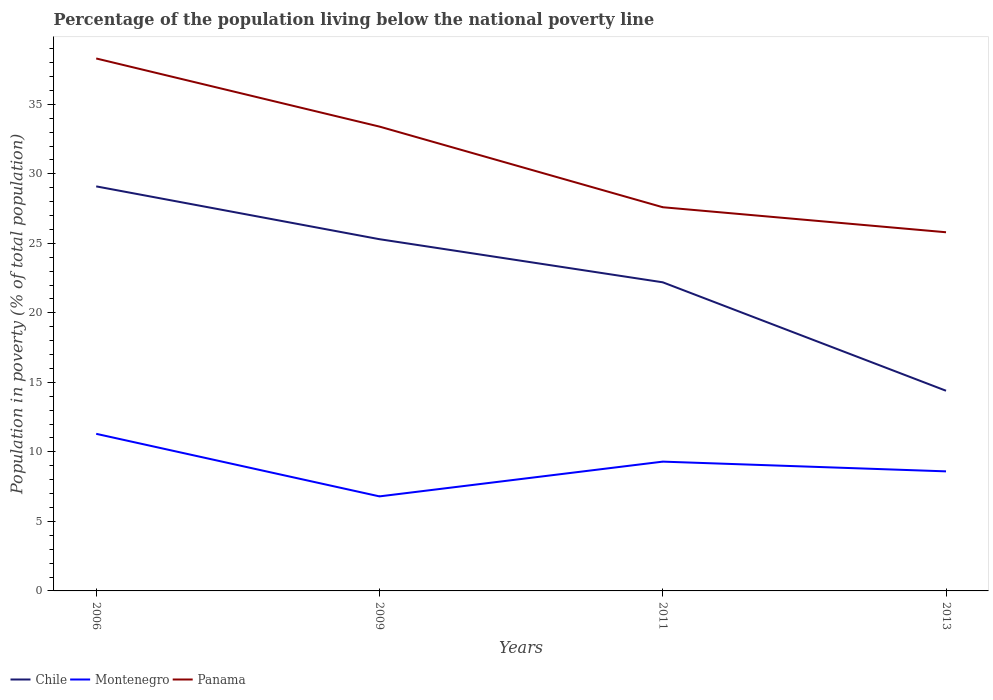How many different coloured lines are there?
Give a very brief answer. 3. Across all years, what is the maximum percentage of the population living below the national poverty line in Montenegro?
Your answer should be very brief. 6.8. In which year was the percentage of the population living below the national poverty line in Panama maximum?
Offer a terse response. 2013. What is the total percentage of the population living below the national poverty line in Montenegro in the graph?
Your answer should be very brief. 0.7. What is the difference between the highest and the second highest percentage of the population living below the national poverty line in Panama?
Give a very brief answer. 12.5. Is the percentage of the population living below the national poverty line in Panama strictly greater than the percentage of the population living below the national poverty line in Chile over the years?
Give a very brief answer. No. How many lines are there?
Keep it short and to the point. 3. What is the difference between two consecutive major ticks on the Y-axis?
Offer a terse response. 5. Are the values on the major ticks of Y-axis written in scientific E-notation?
Provide a short and direct response. No. What is the title of the graph?
Offer a very short reply. Percentage of the population living below the national poverty line. What is the label or title of the Y-axis?
Give a very brief answer. Population in poverty (% of total population). What is the Population in poverty (% of total population) in Chile in 2006?
Make the answer very short. 29.1. What is the Population in poverty (% of total population) in Montenegro in 2006?
Make the answer very short. 11.3. What is the Population in poverty (% of total population) of Panama in 2006?
Make the answer very short. 38.3. What is the Population in poverty (% of total population) of Chile in 2009?
Give a very brief answer. 25.3. What is the Population in poverty (% of total population) of Montenegro in 2009?
Give a very brief answer. 6.8. What is the Population in poverty (% of total population) in Panama in 2009?
Give a very brief answer. 33.4. What is the Population in poverty (% of total population) in Chile in 2011?
Provide a succinct answer. 22.2. What is the Population in poverty (% of total population) of Montenegro in 2011?
Keep it short and to the point. 9.3. What is the Population in poverty (% of total population) of Panama in 2011?
Your response must be concise. 27.6. What is the Population in poverty (% of total population) of Chile in 2013?
Offer a very short reply. 14.4. What is the Population in poverty (% of total population) in Montenegro in 2013?
Provide a short and direct response. 8.6. What is the Population in poverty (% of total population) in Panama in 2013?
Your response must be concise. 25.8. Across all years, what is the maximum Population in poverty (% of total population) in Chile?
Offer a terse response. 29.1. Across all years, what is the maximum Population in poverty (% of total population) in Montenegro?
Provide a succinct answer. 11.3. Across all years, what is the maximum Population in poverty (% of total population) of Panama?
Keep it short and to the point. 38.3. Across all years, what is the minimum Population in poverty (% of total population) of Panama?
Your answer should be very brief. 25.8. What is the total Population in poverty (% of total population) in Chile in the graph?
Ensure brevity in your answer.  91. What is the total Population in poverty (% of total population) of Montenegro in the graph?
Your response must be concise. 36. What is the total Population in poverty (% of total population) in Panama in the graph?
Offer a very short reply. 125.1. What is the difference between the Population in poverty (% of total population) in Montenegro in 2006 and that in 2009?
Provide a succinct answer. 4.5. What is the difference between the Population in poverty (% of total population) in Montenegro in 2006 and that in 2011?
Your response must be concise. 2. What is the difference between the Population in poverty (% of total population) in Chile in 2009 and that in 2011?
Make the answer very short. 3.1. What is the difference between the Population in poverty (% of total population) in Montenegro in 2009 and that in 2013?
Your response must be concise. -1.8. What is the difference between the Population in poverty (% of total population) in Montenegro in 2011 and that in 2013?
Your response must be concise. 0.7. What is the difference between the Population in poverty (% of total population) in Chile in 2006 and the Population in poverty (% of total population) in Montenegro in 2009?
Your answer should be compact. 22.3. What is the difference between the Population in poverty (% of total population) of Montenegro in 2006 and the Population in poverty (% of total population) of Panama in 2009?
Provide a succinct answer. -22.1. What is the difference between the Population in poverty (% of total population) in Chile in 2006 and the Population in poverty (% of total population) in Montenegro in 2011?
Your answer should be compact. 19.8. What is the difference between the Population in poverty (% of total population) in Montenegro in 2006 and the Population in poverty (% of total population) in Panama in 2011?
Your answer should be compact. -16.3. What is the difference between the Population in poverty (% of total population) in Montenegro in 2006 and the Population in poverty (% of total population) in Panama in 2013?
Provide a succinct answer. -14.5. What is the difference between the Population in poverty (% of total population) in Montenegro in 2009 and the Population in poverty (% of total population) in Panama in 2011?
Offer a terse response. -20.8. What is the difference between the Population in poverty (% of total population) of Chile in 2009 and the Population in poverty (% of total population) of Montenegro in 2013?
Offer a very short reply. 16.7. What is the difference between the Population in poverty (% of total population) in Chile in 2009 and the Population in poverty (% of total population) in Panama in 2013?
Your response must be concise. -0.5. What is the difference between the Population in poverty (% of total population) in Chile in 2011 and the Population in poverty (% of total population) in Panama in 2013?
Give a very brief answer. -3.6. What is the difference between the Population in poverty (% of total population) in Montenegro in 2011 and the Population in poverty (% of total population) in Panama in 2013?
Your answer should be very brief. -16.5. What is the average Population in poverty (% of total population) in Chile per year?
Your response must be concise. 22.75. What is the average Population in poverty (% of total population) of Panama per year?
Your response must be concise. 31.27. In the year 2006, what is the difference between the Population in poverty (% of total population) in Montenegro and Population in poverty (% of total population) in Panama?
Provide a succinct answer. -27. In the year 2009, what is the difference between the Population in poverty (% of total population) of Montenegro and Population in poverty (% of total population) of Panama?
Give a very brief answer. -26.6. In the year 2011, what is the difference between the Population in poverty (% of total population) of Chile and Population in poverty (% of total population) of Montenegro?
Provide a succinct answer. 12.9. In the year 2011, what is the difference between the Population in poverty (% of total population) of Montenegro and Population in poverty (% of total population) of Panama?
Your answer should be very brief. -18.3. In the year 2013, what is the difference between the Population in poverty (% of total population) in Chile and Population in poverty (% of total population) in Montenegro?
Ensure brevity in your answer.  5.8. In the year 2013, what is the difference between the Population in poverty (% of total population) of Montenegro and Population in poverty (% of total population) of Panama?
Your response must be concise. -17.2. What is the ratio of the Population in poverty (% of total population) in Chile in 2006 to that in 2009?
Provide a succinct answer. 1.15. What is the ratio of the Population in poverty (% of total population) of Montenegro in 2006 to that in 2009?
Offer a terse response. 1.66. What is the ratio of the Population in poverty (% of total population) of Panama in 2006 to that in 2009?
Provide a short and direct response. 1.15. What is the ratio of the Population in poverty (% of total population) of Chile in 2006 to that in 2011?
Make the answer very short. 1.31. What is the ratio of the Population in poverty (% of total population) of Montenegro in 2006 to that in 2011?
Provide a succinct answer. 1.22. What is the ratio of the Population in poverty (% of total population) in Panama in 2006 to that in 2011?
Offer a terse response. 1.39. What is the ratio of the Population in poverty (% of total population) in Chile in 2006 to that in 2013?
Your answer should be compact. 2.02. What is the ratio of the Population in poverty (% of total population) in Montenegro in 2006 to that in 2013?
Offer a very short reply. 1.31. What is the ratio of the Population in poverty (% of total population) of Panama in 2006 to that in 2013?
Your answer should be very brief. 1.48. What is the ratio of the Population in poverty (% of total population) of Chile in 2009 to that in 2011?
Keep it short and to the point. 1.14. What is the ratio of the Population in poverty (% of total population) of Montenegro in 2009 to that in 2011?
Keep it short and to the point. 0.73. What is the ratio of the Population in poverty (% of total population) of Panama in 2009 to that in 2011?
Your answer should be compact. 1.21. What is the ratio of the Population in poverty (% of total population) in Chile in 2009 to that in 2013?
Keep it short and to the point. 1.76. What is the ratio of the Population in poverty (% of total population) of Montenegro in 2009 to that in 2013?
Keep it short and to the point. 0.79. What is the ratio of the Population in poverty (% of total population) of Panama in 2009 to that in 2013?
Offer a very short reply. 1.29. What is the ratio of the Population in poverty (% of total population) in Chile in 2011 to that in 2013?
Provide a short and direct response. 1.54. What is the ratio of the Population in poverty (% of total population) of Montenegro in 2011 to that in 2013?
Offer a terse response. 1.08. What is the ratio of the Population in poverty (% of total population) of Panama in 2011 to that in 2013?
Provide a succinct answer. 1.07. What is the difference between the highest and the second highest Population in poverty (% of total population) in Montenegro?
Give a very brief answer. 2. What is the difference between the highest and the second highest Population in poverty (% of total population) in Panama?
Your answer should be compact. 4.9. What is the difference between the highest and the lowest Population in poverty (% of total population) of Chile?
Ensure brevity in your answer.  14.7. What is the difference between the highest and the lowest Population in poverty (% of total population) of Montenegro?
Provide a succinct answer. 4.5. 